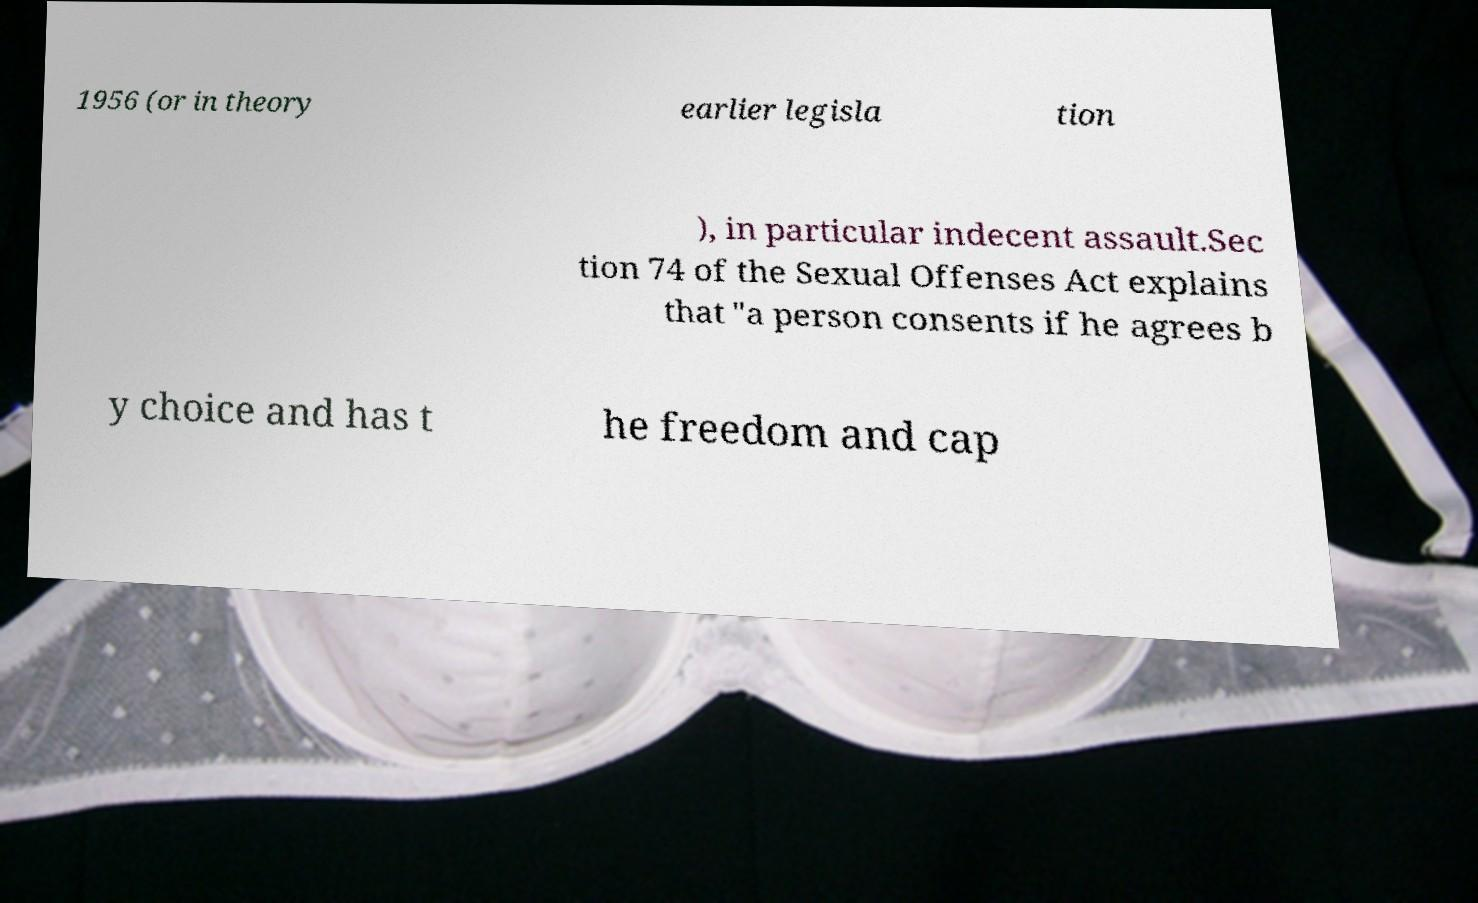What messages or text are displayed in this image? I need them in a readable, typed format. 1956 (or in theory earlier legisla tion ), in particular indecent assault.Sec tion 74 of the Sexual Offenses Act explains that "a person consents if he agrees b y choice and has t he freedom and cap 